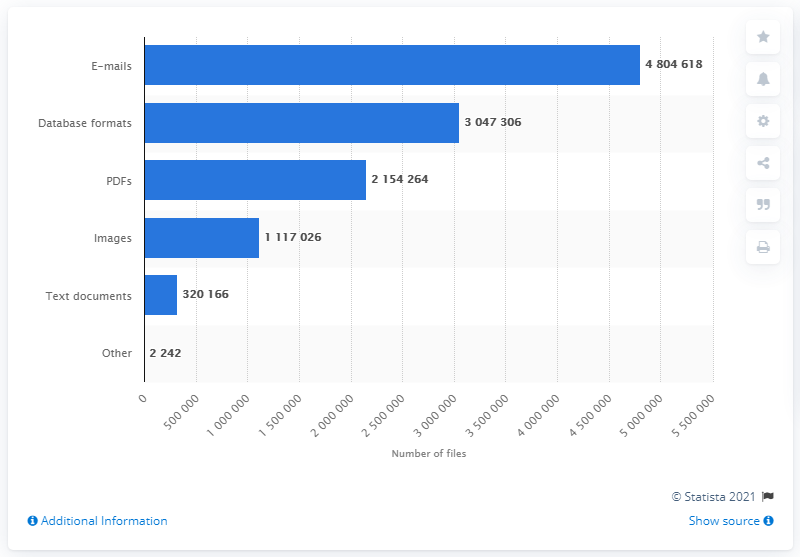List a handful of essential elements in this visual. In April 2016, a total of 2154264 PDFs were leaked. 